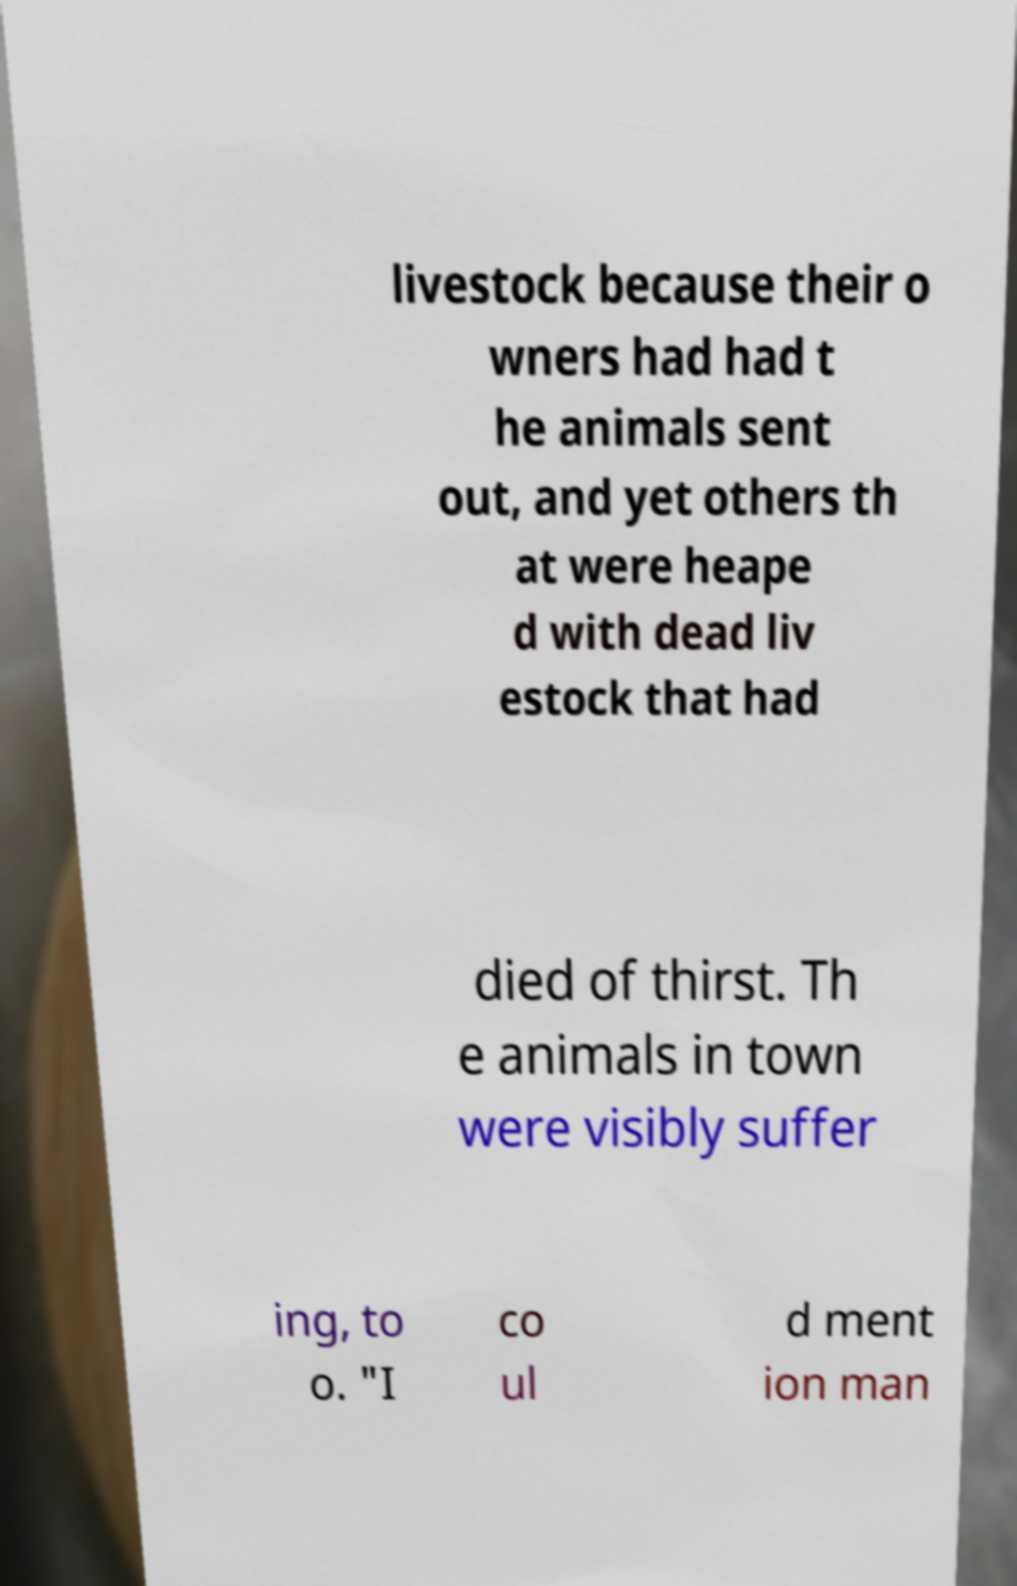For documentation purposes, I need the text within this image transcribed. Could you provide that? livestock because their o wners had had t he animals sent out, and yet others th at were heape d with dead liv estock that had died of thirst. Th e animals in town were visibly suffer ing, to o. "I co ul d ment ion man 